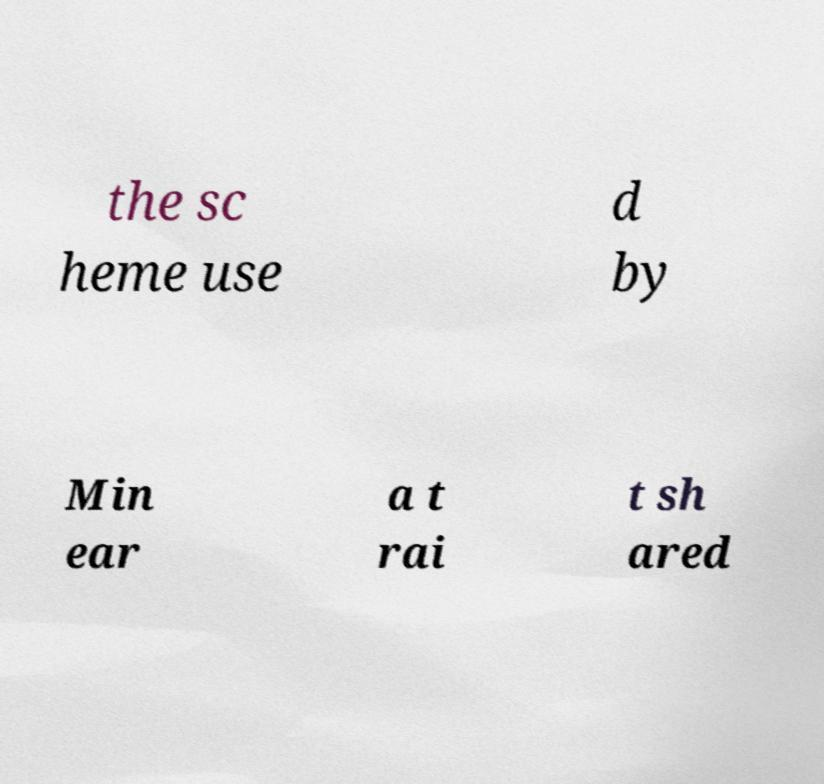I need the written content from this picture converted into text. Can you do that? the sc heme use d by Min ear a t rai t sh ared 